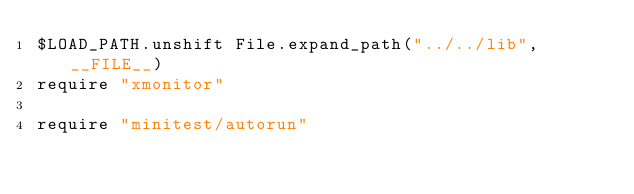Convert code to text. <code><loc_0><loc_0><loc_500><loc_500><_Ruby_>$LOAD_PATH.unshift File.expand_path("../../lib", __FILE__)
require "xmonitor"

require "minitest/autorun"
</code> 